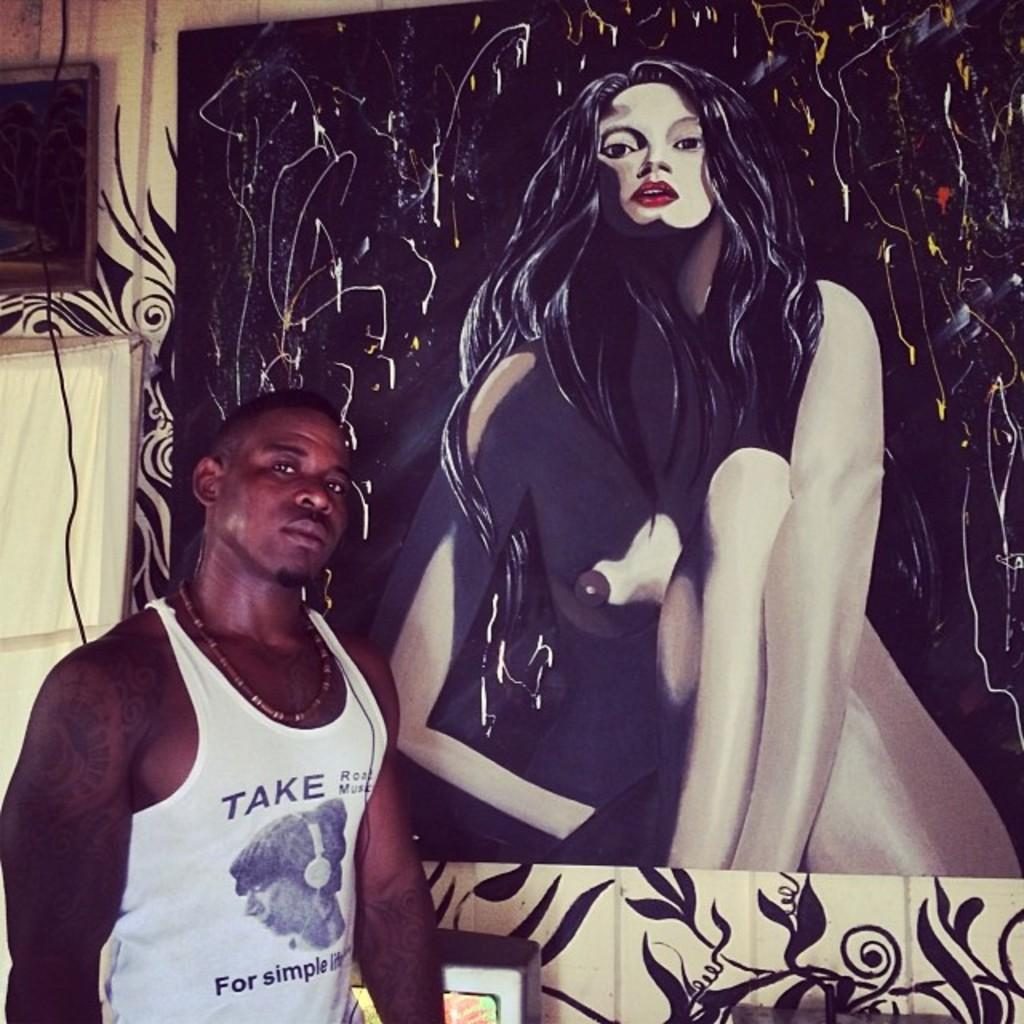<image>
Share a concise interpretation of the image provided. A man wearing a white tank top with the words Take Road Music on it is posing in front of a painting of a nude woman with long black hair. 